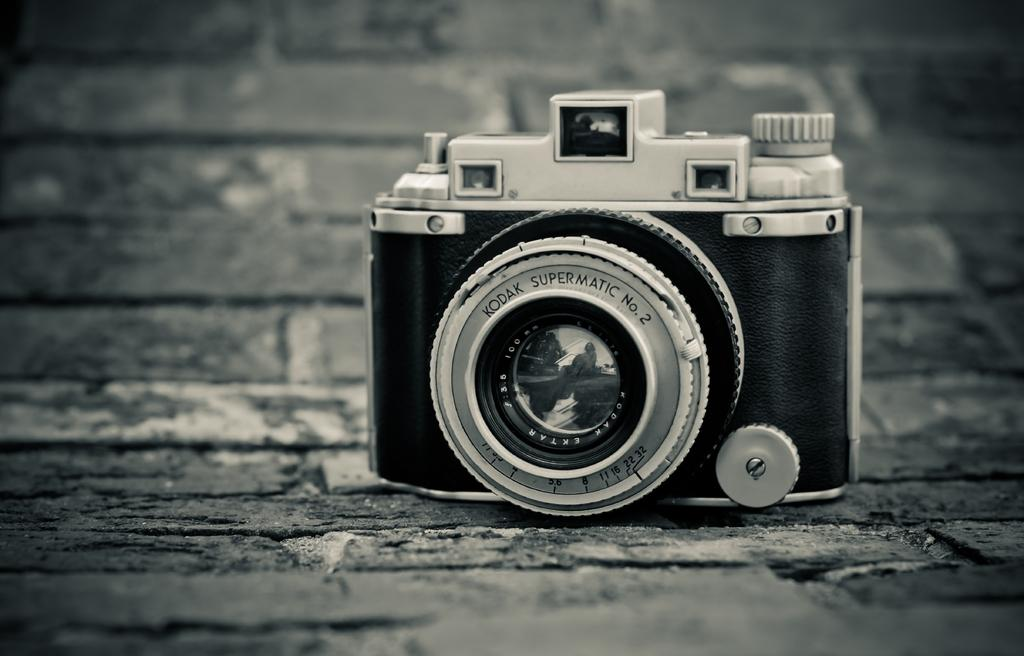What is the main subject in the foreground of the image? There is a camera in the foreground of the image. Can you describe the position of the camera in the image? The camera is on a surface. What type of behavior does the robin exhibit in the image? There is no robin present in the image, so it is not possible to describe its behavior. 